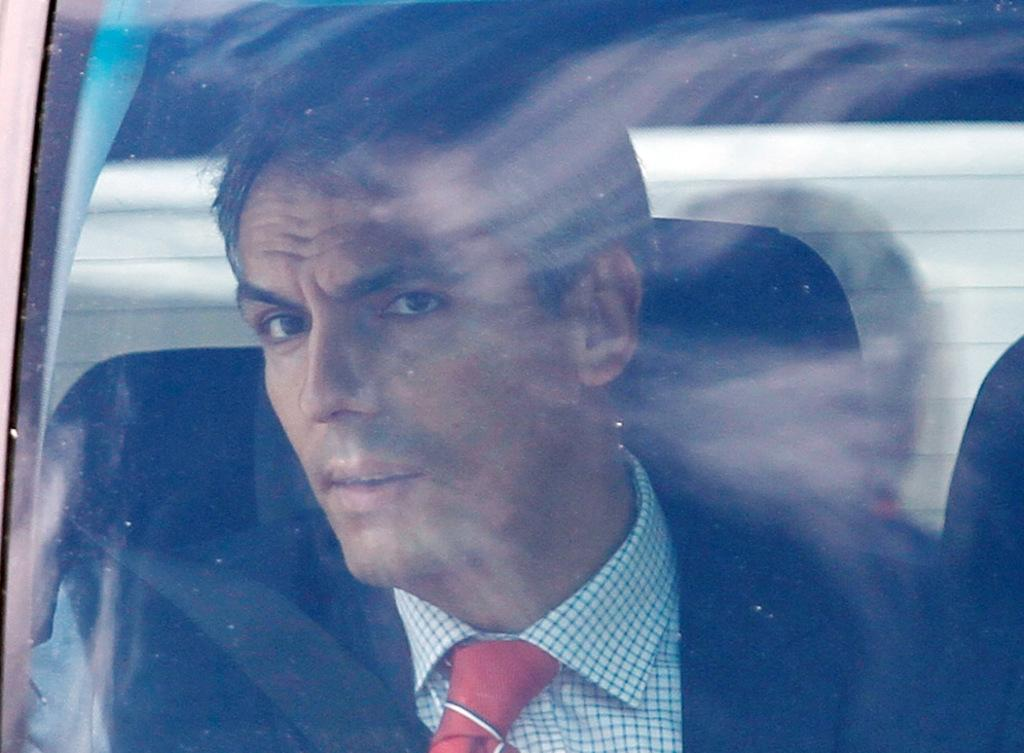What is the main subject of the image? There is a person in the image. What is the person doing in the image? The person is sitting in a car. What type of marble is visible in the image? There is no marble present in the image. What is the person's grade in the image? The image does not provide any information about the person's grade. 